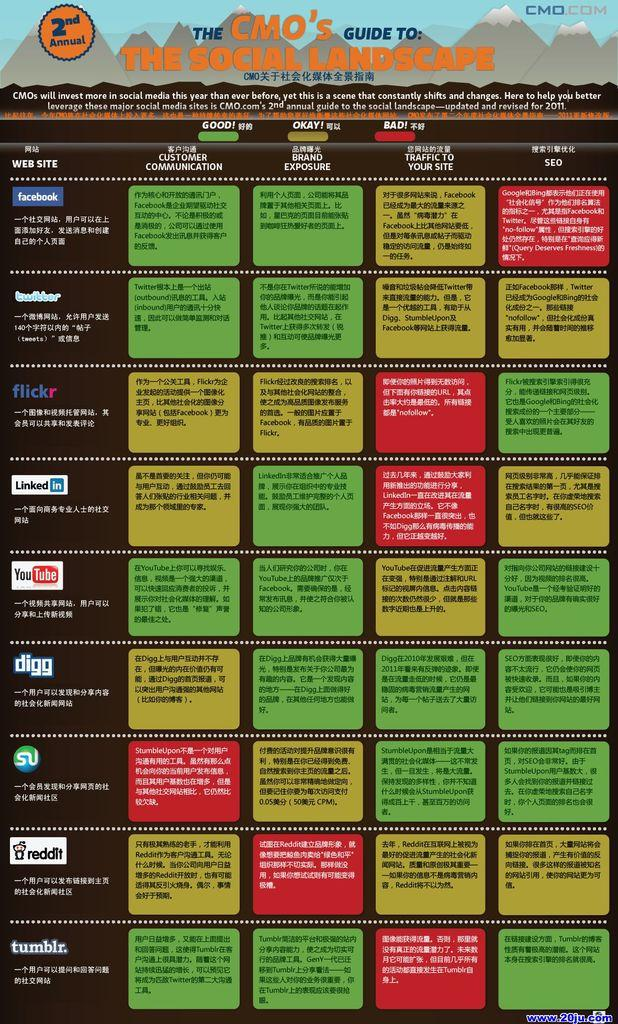Provide a one-sentence caption for the provided image. A poster of 'The CMO's guide to the social landscape'. 